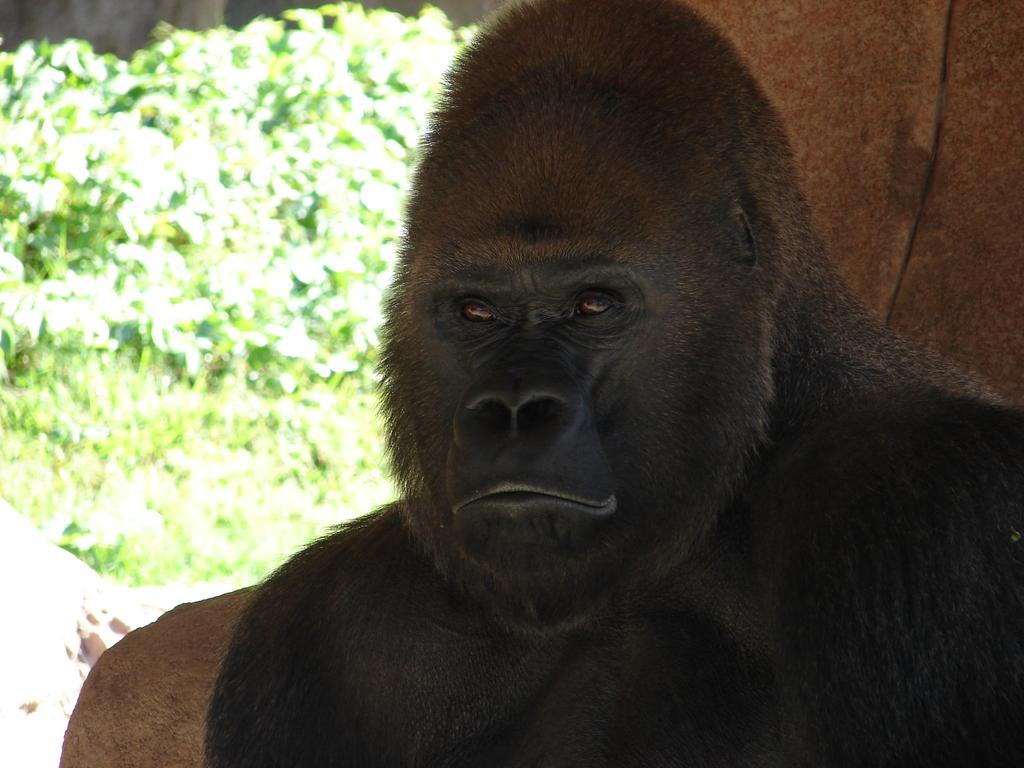What animal is the main subject of the image? There is a gorilla in the image. What can be seen in the background of the image? There is a wall and leaves visible in the background of the image. How would you describe the appearance of the background? The background appears blurry. How many kitties are sitting on the gorilla's legs in the image? There are no kitties or legs visible in the image; it features a gorilla and a blurry background. 